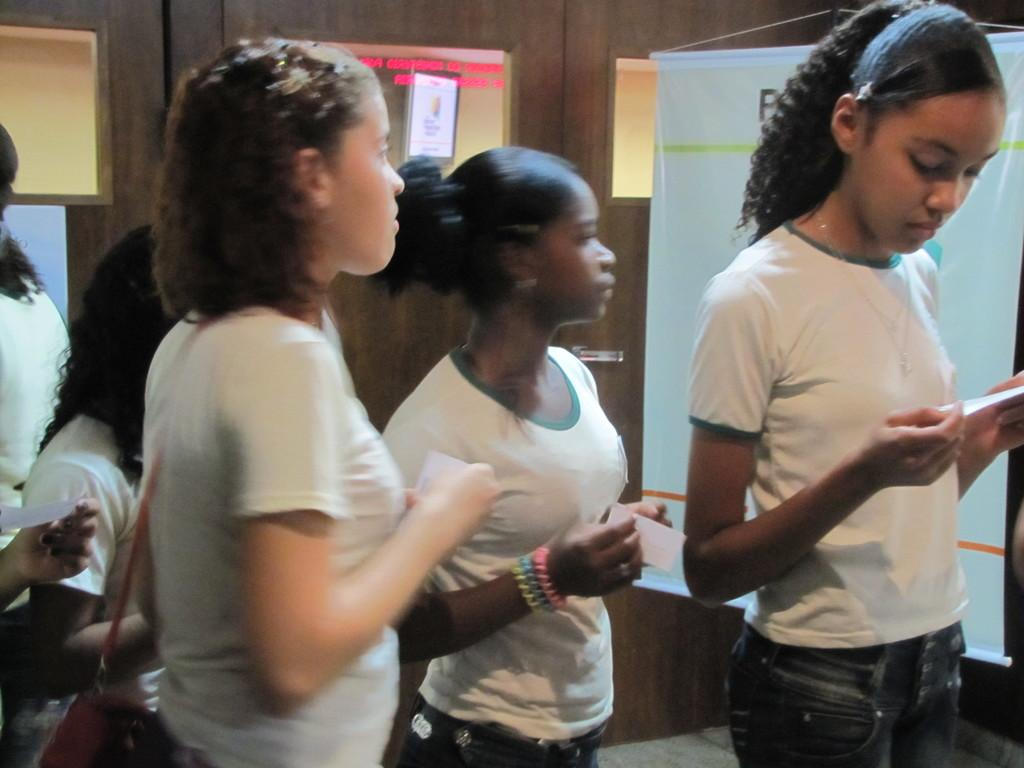What are the women in the image doing? The women in the image are standing in the middle of the image and holding papers. What can be seen in the background of the image? There is a wall in the background of the image. Is there anything on the wall in the image? Yes, there is a banner on the wall. What type of crack is visible on the head of the woman in the image? There is no crack visible on the head of any woman in the image. 